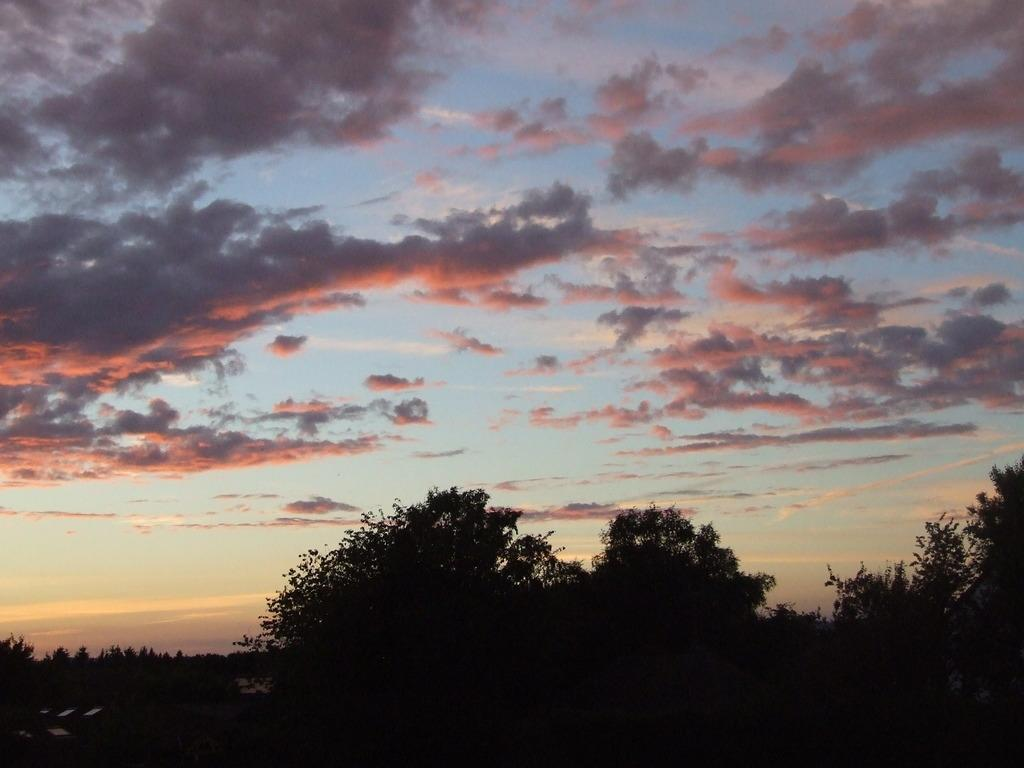What type of vegetation is visible in the front of the image? There are trees in the front of the image. What can be seen in the background of the image? There are clouds and the sky visible in the background of the image. Where is the shelf located in the image? There is no shelf present in the image. What type of nerve can be seen in the image? There are no nerves present in the image; it features trees and clouds. 